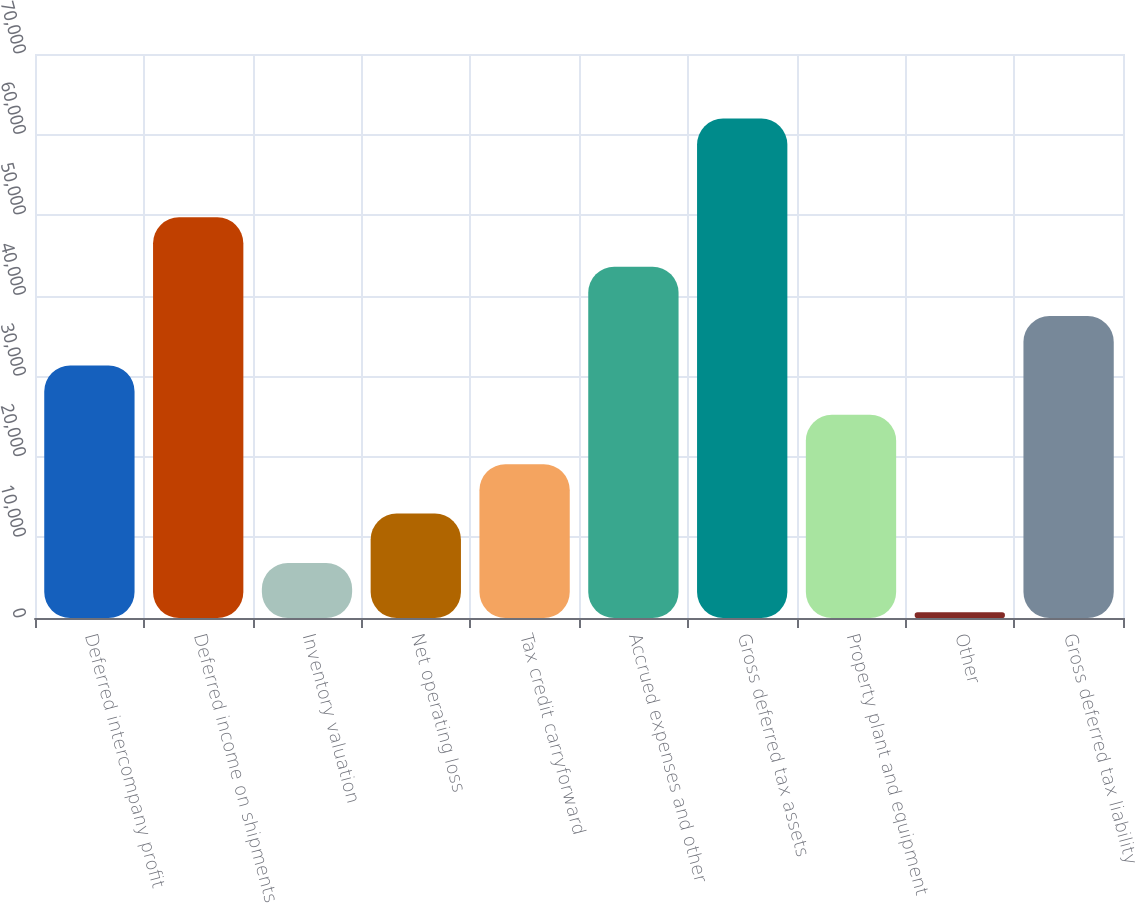Convert chart. <chart><loc_0><loc_0><loc_500><loc_500><bar_chart><fcel>Deferred intercompany profit<fcel>Deferred income on shipments<fcel>Inventory valuation<fcel>Net operating loss<fcel>Tax credit carryforward<fcel>Accrued expenses and other<fcel>Gross deferred tax assets<fcel>Property plant and equipment<fcel>Other<fcel>Gross deferred tax liability<nl><fcel>31347.5<fcel>49728.8<fcel>6839.1<fcel>12966.2<fcel>19093.3<fcel>43601.7<fcel>61983<fcel>25220.4<fcel>712<fcel>37474.6<nl></chart> 